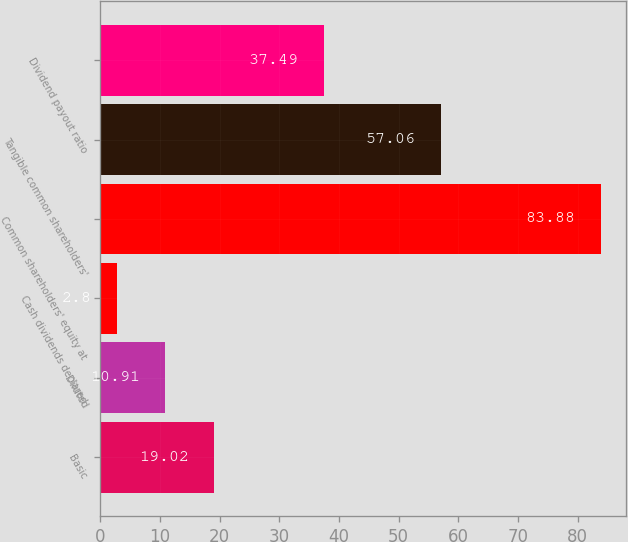<chart> <loc_0><loc_0><loc_500><loc_500><bar_chart><fcel>Basic<fcel>Diluted<fcel>Cash dividends declared<fcel>Common shareholders' equity at<fcel>Tangible common shareholders'<fcel>Dividend payout ratio<nl><fcel>19.02<fcel>10.91<fcel>2.8<fcel>83.88<fcel>57.06<fcel>37.49<nl></chart> 